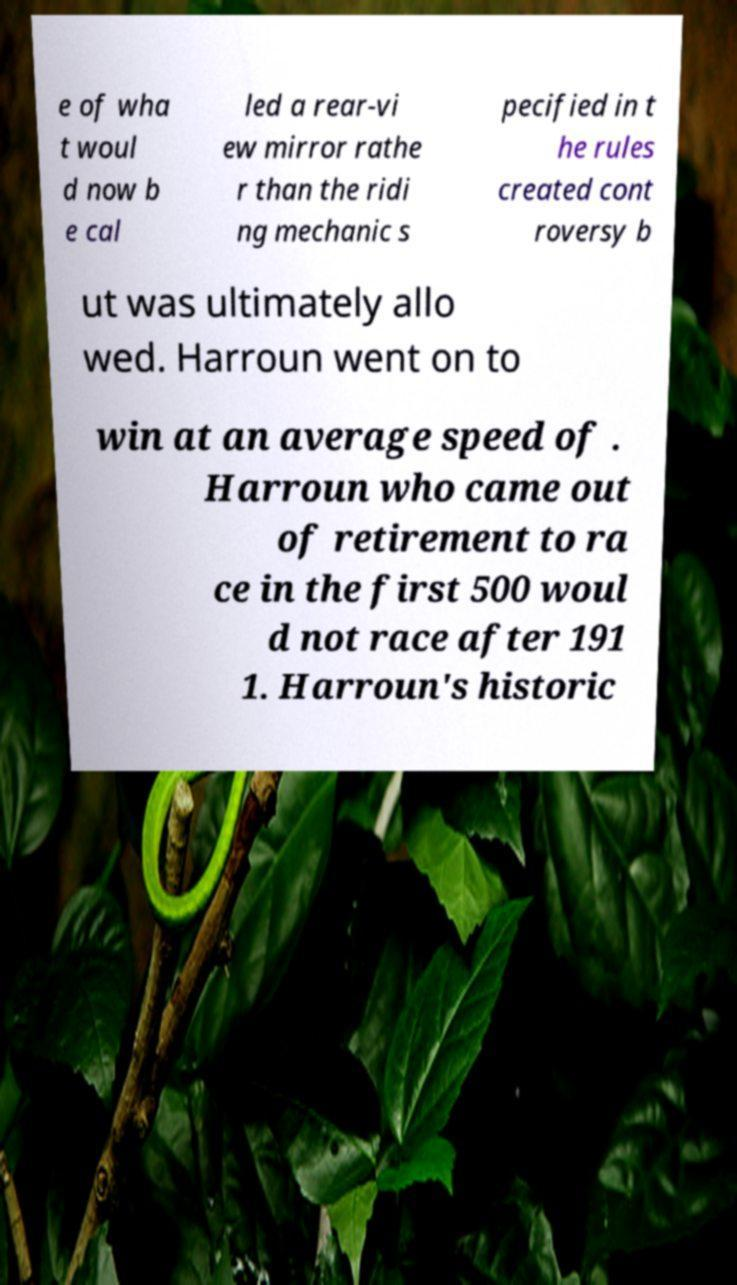I need the written content from this picture converted into text. Can you do that? e of wha t woul d now b e cal led a rear-vi ew mirror rathe r than the ridi ng mechanic s pecified in t he rules created cont roversy b ut was ultimately allo wed. Harroun went on to win at an average speed of . Harroun who came out of retirement to ra ce in the first 500 woul d not race after 191 1. Harroun's historic 